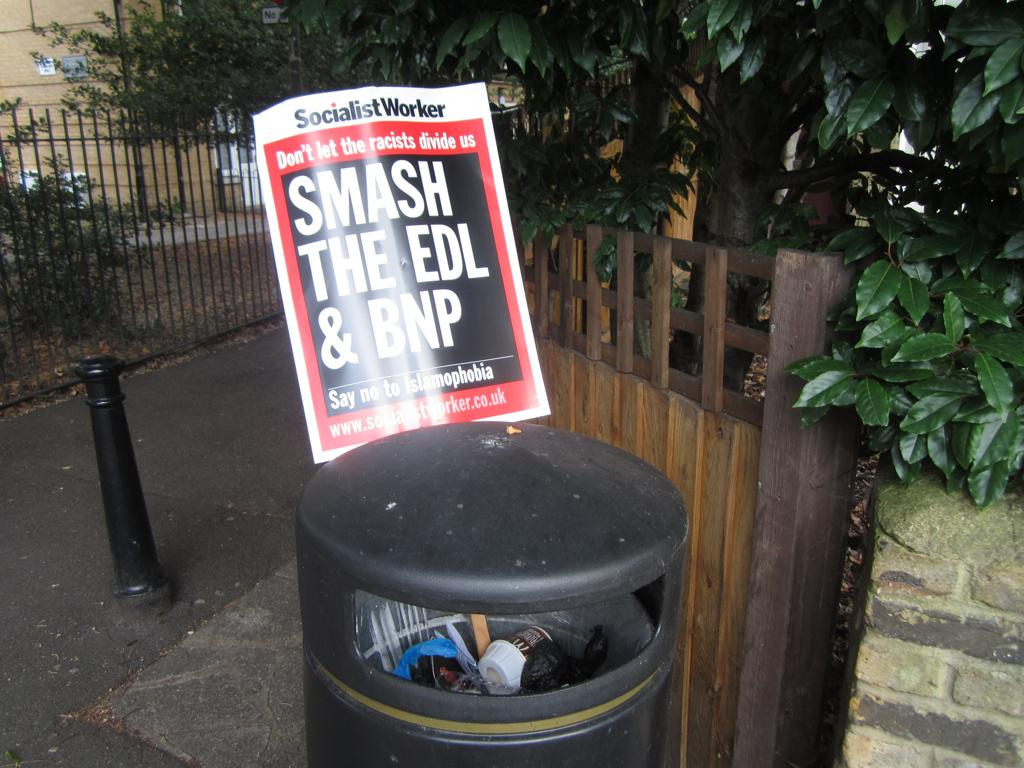<image>
Share a concise interpretation of the image provided. a smash the EDL title on a paper 